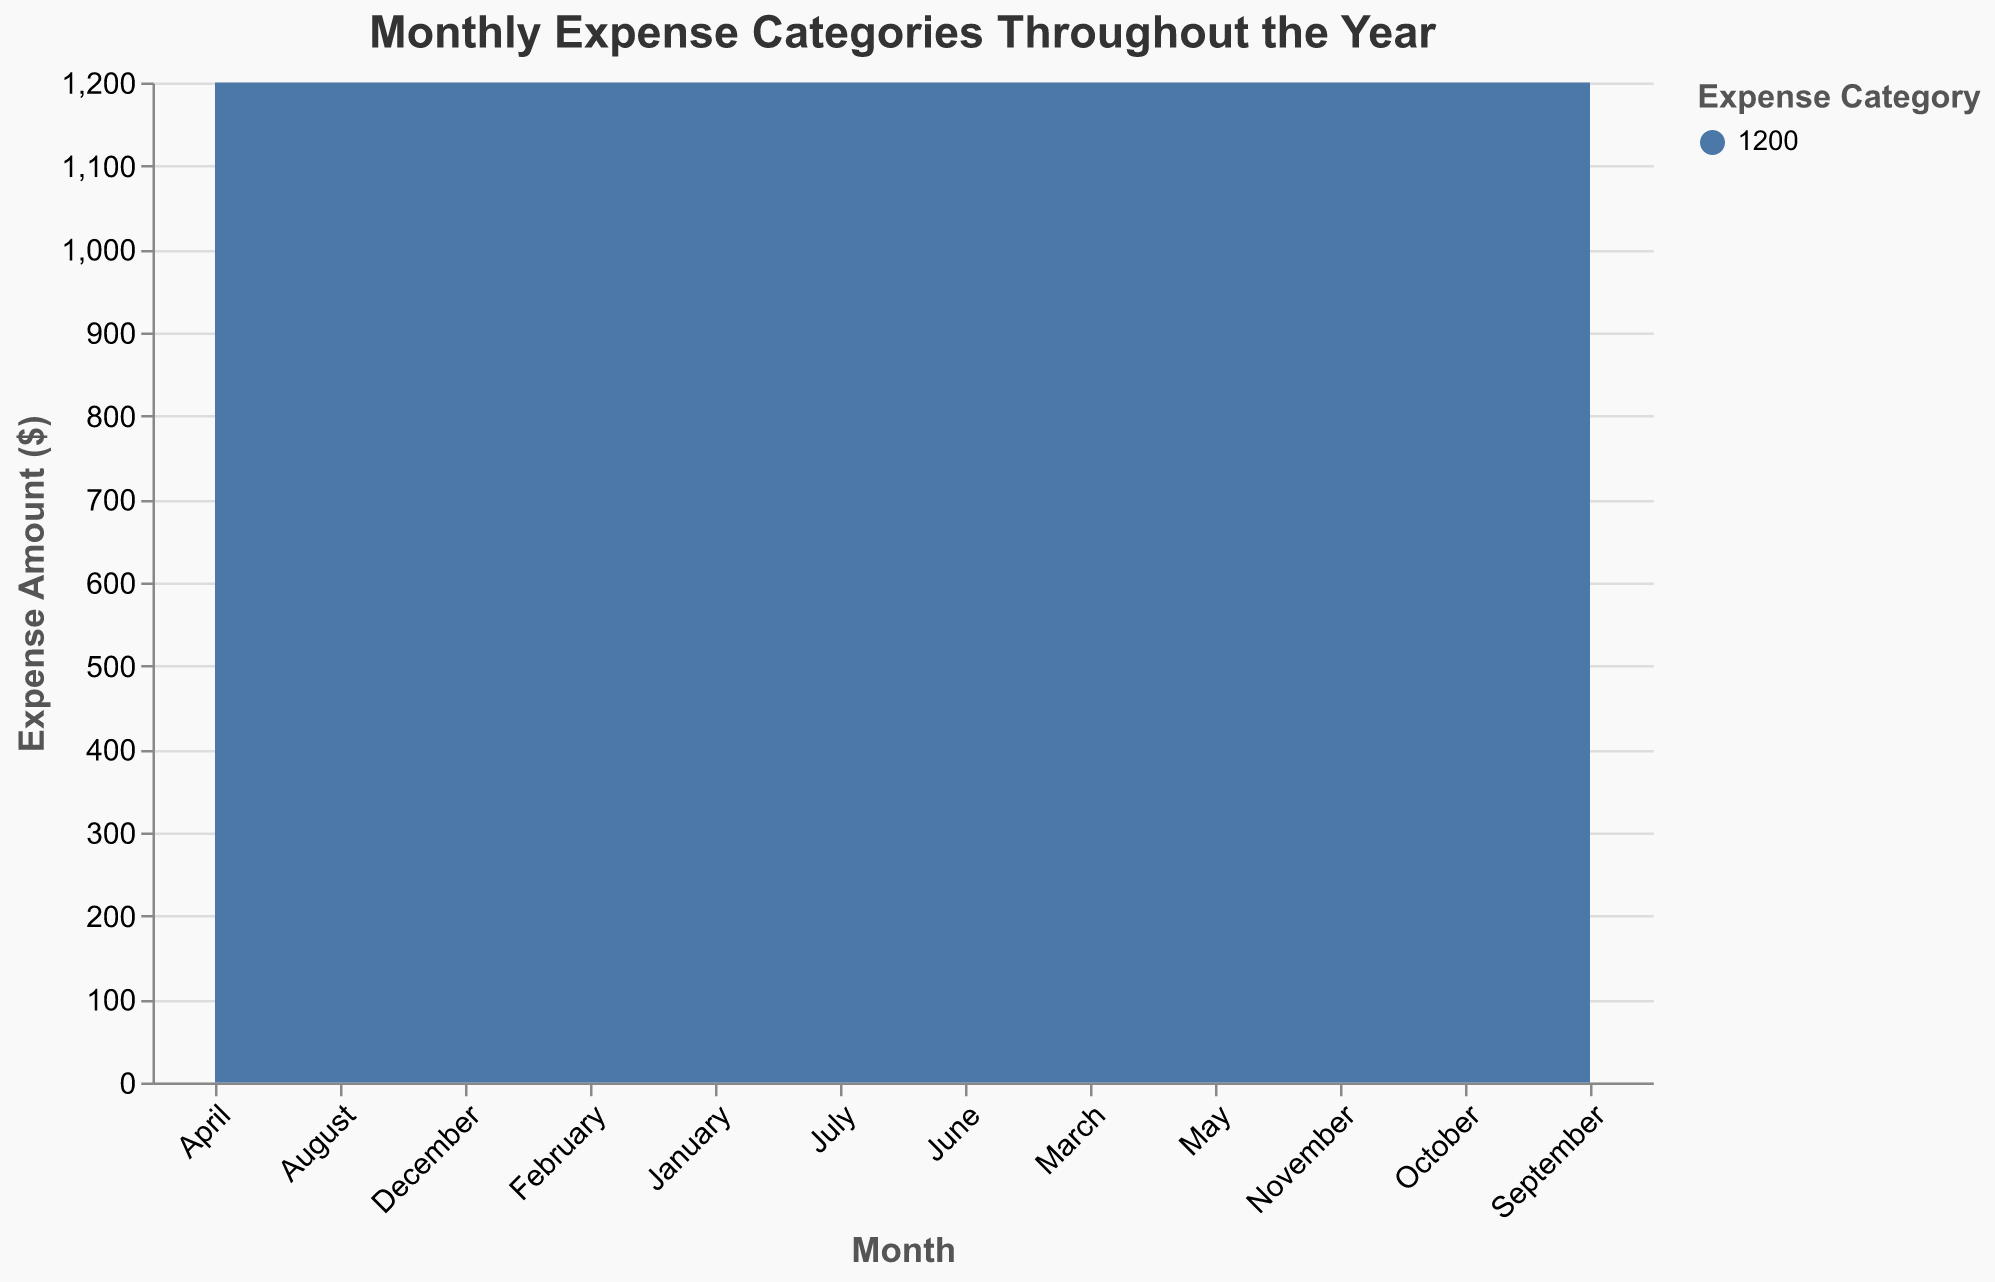What is the title of the chart? The title can be found at the top of the chart, which is usually highlighted and larger than the other text elements.
Answer: Monthly Expense Categories Throughout the Year Which month had the highest total expenses? To determine the month with the highest total expenses, compare the sum of the stacked areas (representing different expense categories) for each month. The highest point on the y-axis will indicate the month with the maximum expenses.
Answer: November What does the x-axis represent? The x-axis shows the time dimension, which in this case refers to the months of the year from January to December. This can be inferred from the labels on the x-axis.
Answer: Months of the year Which category saw the most significant increase from January to December? To identify which expense category had the most significant increase, compare the heights of the stacked areas at January and December for each category. The category with the largest vertical change between these two months will be the one with the most significant increase.
Answer: Groceries In which month did Miscellaneous expenses peak? Look at the segment of the stacked area corresponding to "Miscellaneous". The peak point is where this layer reaches its highest point on the y-axis in any month.
Answer: August How did Utilities expenses change from January to June? To see how Utilities expenses changed, follow the portion of the stacked area representing Utilities from January to June. Note the change in its height during this period.
Answer: Increased from 150 to 165 Was there a month when Transportation expenses decreased compared to the previous month? If so, which month? Examine the stacked area segment for Transportation and compare its height month to month. Identify any instance where the height decreases instead of increasing.
Answer: February Which expense category remained constant throughout the year? To find a category that remained constant, look for a horizontal segment in the stacked area that shows no change in height across all months.
Answer: Rent/Mortgage Which month had the highest Miscellaneous expenses in the second half of the year? Focus on the months from July to December and check the highest point of the stacked area segment for Miscellaneous expenses during this period.
Answer: August How do the total expenses in July compare to those in December? To compare the total expenses, note the sum of the heights of all stacked segments (categories) for both July and December. Observe which month has a higher y-axis value.
Answer: July has higher total expenses than December 